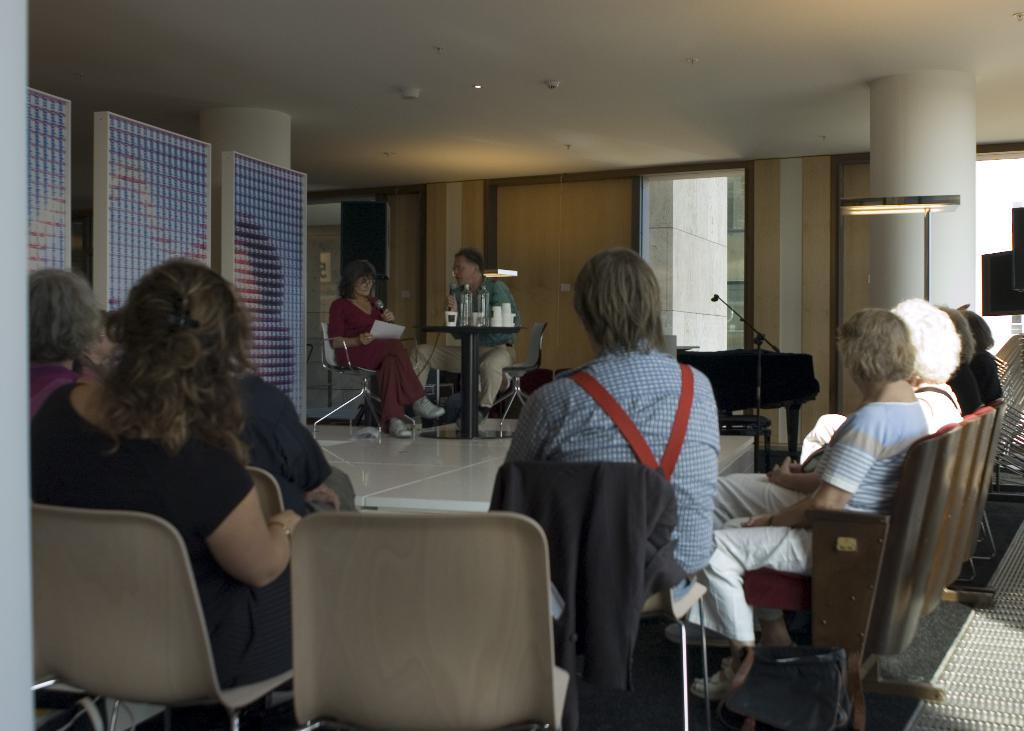What can be seen in the background of the image? There is a wall in the image. What are the people in the image doing? There are people sitting on chairs and on stage in the image. What objects are on the table in the image? There are bottles and glasses on a table in the image. What type of cracker is being used to create friction on the stage in the image? There is no cracker or friction present in the image; it features people sitting on chairs and on stage, as well as bottles and glasses on a table. 